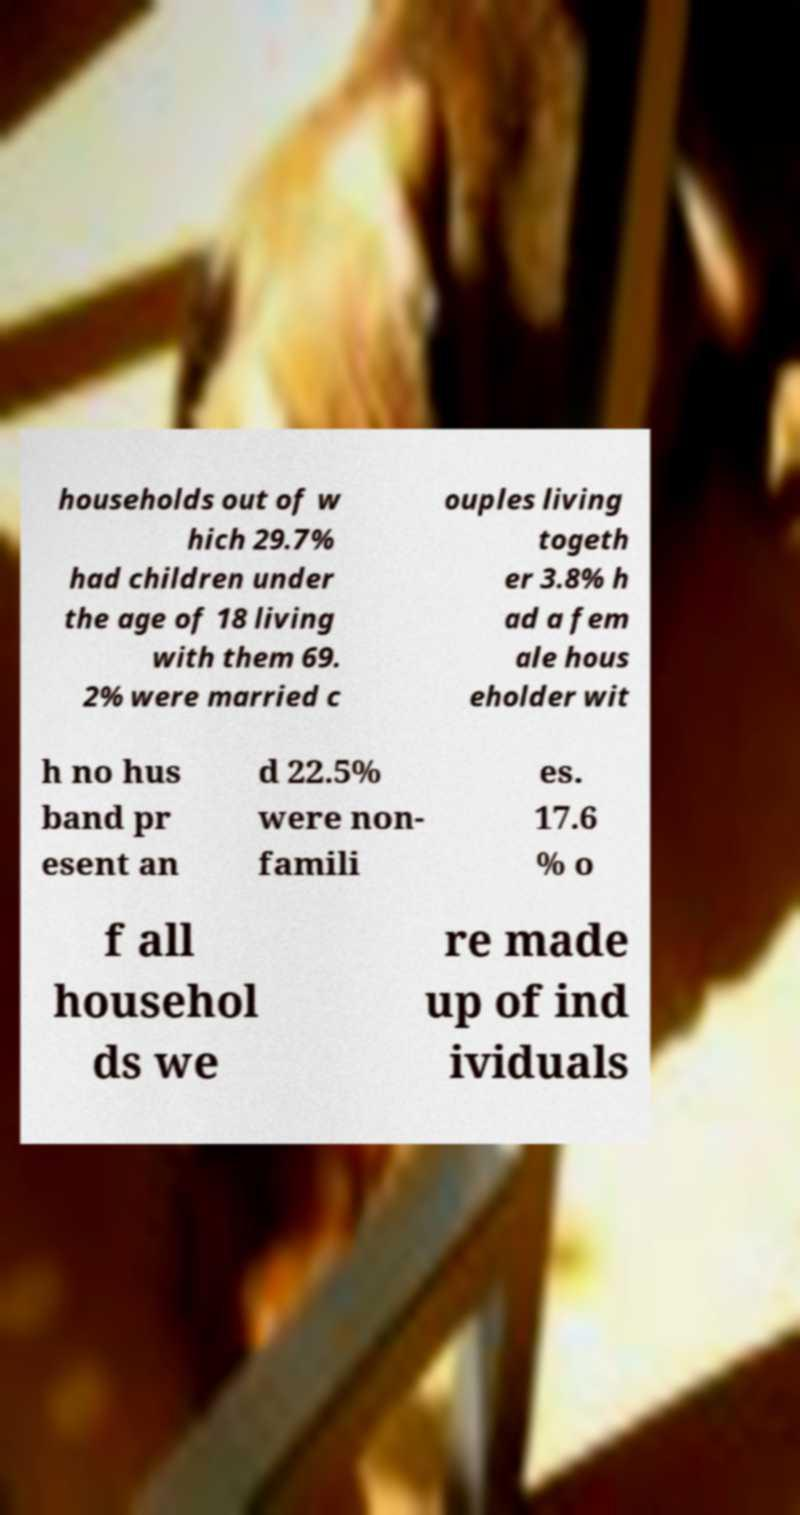I need the written content from this picture converted into text. Can you do that? households out of w hich 29.7% had children under the age of 18 living with them 69. 2% were married c ouples living togeth er 3.8% h ad a fem ale hous eholder wit h no hus band pr esent an d 22.5% were non- famili es. 17.6 % o f all househol ds we re made up of ind ividuals 